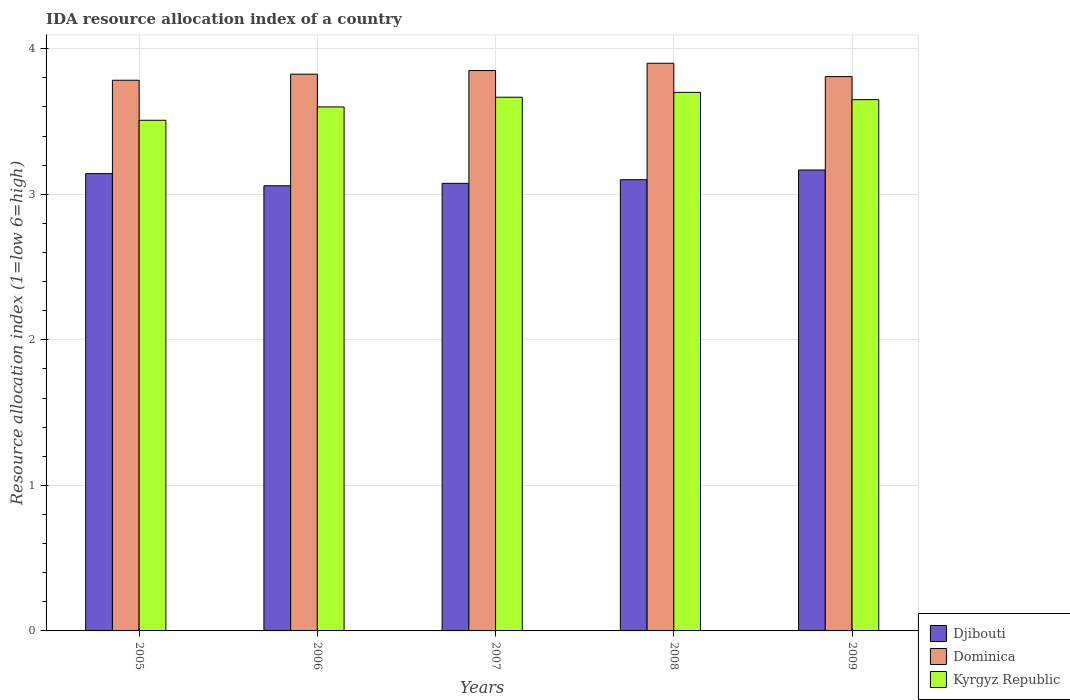How many different coloured bars are there?
Your answer should be very brief. 3. How many groups of bars are there?
Make the answer very short. 5. Are the number of bars per tick equal to the number of legend labels?
Make the answer very short. Yes. How many bars are there on the 5th tick from the left?
Offer a very short reply. 3. How many bars are there on the 3rd tick from the right?
Give a very brief answer. 3. What is the label of the 5th group of bars from the left?
Ensure brevity in your answer.  2009. In how many cases, is the number of bars for a given year not equal to the number of legend labels?
Offer a very short reply. 0. What is the IDA resource allocation index in Djibouti in 2005?
Your answer should be very brief. 3.14. Across all years, what is the minimum IDA resource allocation index in Kyrgyz Republic?
Ensure brevity in your answer.  3.51. In which year was the IDA resource allocation index in Kyrgyz Republic maximum?
Your response must be concise. 2008. What is the total IDA resource allocation index in Kyrgyz Republic in the graph?
Offer a very short reply. 18.12. What is the difference between the IDA resource allocation index in Dominica in 2008 and that in 2009?
Make the answer very short. 0.09. What is the difference between the IDA resource allocation index in Djibouti in 2005 and the IDA resource allocation index in Kyrgyz Republic in 2009?
Give a very brief answer. -0.51. What is the average IDA resource allocation index in Djibouti per year?
Give a very brief answer. 3.11. In the year 2007, what is the difference between the IDA resource allocation index in Dominica and IDA resource allocation index in Kyrgyz Republic?
Your answer should be compact. 0.18. In how many years, is the IDA resource allocation index in Dominica greater than 3.6?
Offer a terse response. 5. What is the ratio of the IDA resource allocation index in Kyrgyz Republic in 2006 to that in 2008?
Your answer should be very brief. 0.97. Is the IDA resource allocation index in Dominica in 2005 less than that in 2009?
Offer a terse response. Yes. What is the difference between the highest and the second highest IDA resource allocation index in Djibouti?
Provide a succinct answer. 0.02. What is the difference between the highest and the lowest IDA resource allocation index in Djibouti?
Your answer should be compact. 0.11. What does the 2nd bar from the left in 2009 represents?
Offer a very short reply. Dominica. What does the 2nd bar from the right in 2009 represents?
Offer a very short reply. Dominica. How many bars are there?
Your answer should be compact. 15. Does the graph contain any zero values?
Offer a very short reply. No. Where does the legend appear in the graph?
Offer a terse response. Bottom right. How are the legend labels stacked?
Your answer should be compact. Vertical. What is the title of the graph?
Give a very brief answer. IDA resource allocation index of a country. What is the label or title of the Y-axis?
Provide a short and direct response. Resource allocation index (1=low 6=high). What is the Resource allocation index (1=low 6=high) in Djibouti in 2005?
Ensure brevity in your answer.  3.14. What is the Resource allocation index (1=low 6=high) of Dominica in 2005?
Keep it short and to the point. 3.78. What is the Resource allocation index (1=low 6=high) of Kyrgyz Republic in 2005?
Provide a succinct answer. 3.51. What is the Resource allocation index (1=low 6=high) in Djibouti in 2006?
Make the answer very short. 3.06. What is the Resource allocation index (1=low 6=high) of Dominica in 2006?
Give a very brief answer. 3.83. What is the Resource allocation index (1=low 6=high) of Kyrgyz Republic in 2006?
Your response must be concise. 3.6. What is the Resource allocation index (1=low 6=high) in Djibouti in 2007?
Give a very brief answer. 3.08. What is the Resource allocation index (1=low 6=high) of Dominica in 2007?
Your answer should be compact. 3.85. What is the Resource allocation index (1=low 6=high) in Kyrgyz Republic in 2007?
Provide a short and direct response. 3.67. What is the Resource allocation index (1=low 6=high) in Kyrgyz Republic in 2008?
Your response must be concise. 3.7. What is the Resource allocation index (1=low 6=high) of Djibouti in 2009?
Provide a succinct answer. 3.17. What is the Resource allocation index (1=low 6=high) of Dominica in 2009?
Keep it short and to the point. 3.81. What is the Resource allocation index (1=low 6=high) in Kyrgyz Republic in 2009?
Your answer should be very brief. 3.65. Across all years, what is the maximum Resource allocation index (1=low 6=high) of Djibouti?
Offer a terse response. 3.17. Across all years, what is the minimum Resource allocation index (1=low 6=high) of Djibouti?
Give a very brief answer. 3.06. Across all years, what is the minimum Resource allocation index (1=low 6=high) of Dominica?
Offer a very short reply. 3.78. Across all years, what is the minimum Resource allocation index (1=low 6=high) in Kyrgyz Republic?
Your answer should be very brief. 3.51. What is the total Resource allocation index (1=low 6=high) of Djibouti in the graph?
Make the answer very short. 15.54. What is the total Resource allocation index (1=low 6=high) in Dominica in the graph?
Provide a short and direct response. 19.17. What is the total Resource allocation index (1=low 6=high) in Kyrgyz Republic in the graph?
Make the answer very short. 18.12. What is the difference between the Resource allocation index (1=low 6=high) of Djibouti in 2005 and that in 2006?
Your answer should be compact. 0.08. What is the difference between the Resource allocation index (1=low 6=high) of Dominica in 2005 and that in 2006?
Your answer should be very brief. -0.04. What is the difference between the Resource allocation index (1=low 6=high) of Kyrgyz Republic in 2005 and that in 2006?
Offer a terse response. -0.09. What is the difference between the Resource allocation index (1=low 6=high) in Djibouti in 2005 and that in 2007?
Your response must be concise. 0.07. What is the difference between the Resource allocation index (1=low 6=high) in Dominica in 2005 and that in 2007?
Your answer should be very brief. -0.07. What is the difference between the Resource allocation index (1=low 6=high) in Kyrgyz Republic in 2005 and that in 2007?
Provide a short and direct response. -0.16. What is the difference between the Resource allocation index (1=low 6=high) in Djibouti in 2005 and that in 2008?
Your answer should be compact. 0.04. What is the difference between the Resource allocation index (1=low 6=high) of Dominica in 2005 and that in 2008?
Offer a very short reply. -0.12. What is the difference between the Resource allocation index (1=low 6=high) in Kyrgyz Republic in 2005 and that in 2008?
Provide a succinct answer. -0.19. What is the difference between the Resource allocation index (1=low 6=high) in Djibouti in 2005 and that in 2009?
Your answer should be very brief. -0.03. What is the difference between the Resource allocation index (1=low 6=high) in Dominica in 2005 and that in 2009?
Your answer should be very brief. -0.03. What is the difference between the Resource allocation index (1=low 6=high) in Kyrgyz Republic in 2005 and that in 2009?
Offer a terse response. -0.14. What is the difference between the Resource allocation index (1=low 6=high) of Djibouti in 2006 and that in 2007?
Your response must be concise. -0.02. What is the difference between the Resource allocation index (1=low 6=high) in Dominica in 2006 and that in 2007?
Make the answer very short. -0.03. What is the difference between the Resource allocation index (1=low 6=high) of Kyrgyz Republic in 2006 and that in 2007?
Give a very brief answer. -0.07. What is the difference between the Resource allocation index (1=low 6=high) of Djibouti in 2006 and that in 2008?
Make the answer very short. -0.04. What is the difference between the Resource allocation index (1=low 6=high) in Dominica in 2006 and that in 2008?
Provide a succinct answer. -0.07. What is the difference between the Resource allocation index (1=low 6=high) of Kyrgyz Republic in 2006 and that in 2008?
Give a very brief answer. -0.1. What is the difference between the Resource allocation index (1=low 6=high) of Djibouti in 2006 and that in 2009?
Provide a short and direct response. -0.11. What is the difference between the Resource allocation index (1=low 6=high) in Dominica in 2006 and that in 2009?
Offer a terse response. 0.02. What is the difference between the Resource allocation index (1=low 6=high) in Kyrgyz Republic in 2006 and that in 2009?
Provide a short and direct response. -0.05. What is the difference between the Resource allocation index (1=low 6=high) in Djibouti in 2007 and that in 2008?
Make the answer very short. -0.03. What is the difference between the Resource allocation index (1=low 6=high) in Dominica in 2007 and that in 2008?
Provide a short and direct response. -0.05. What is the difference between the Resource allocation index (1=low 6=high) of Kyrgyz Republic in 2007 and that in 2008?
Offer a terse response. -0.03. What is the difference between the Resource allocation index (1=low 6=high) in Djibouti in 2007 and that in 2009?
Keep it short and to the point. -0.09. What is the difference between the Resource allocation index (1=low 6=high) in Dominica in 2007 and that in 2009?
Make the answer very short. 0.04. What is the difference between the Resource allocation index (1=low 6=high) in Kyrgyz Republic in 2007 and that in 2009?
Your response must be concise. 0.02. What is the difference between the Resource allocation index (1=low 6=high) of Djibouti in 2008 and that in 2009?
Offer a terse response. -0.07. What is the difference between the Resource allocation index (1=low 6=high) of Dominica in 2008 and that in 2009?
Provide a short and direct response. 0.09. What is the difference between the Resource allocation index (1=low 6=high) in Kyrgyz Republic in 2008 and that in 2009?
Your answer should be very brief. 0.05. What is the difference between the Resource allocation index (1=low 6=high) of Djibouti in 2005 and the Resource allocation index (1=low 6=high) of Dominica in 2006?
Give a very brief answer. -0.68. What is the difference between the Resource allocation index (1=low 6=high) in Djibouti in 2005 and the Resource allocation index (1=low 6=high) in Kyrgyz Republic in 2006?
Your response must be concise. -0.46. What is the difference between the Resource allocation index (1=low 6=high) in Dominica in 2005 and the Resource allocation index (1=low 6=high) in Kyrgyz Republic in 2006?
Make the answer very short. 0.18. What is the difference between the Resource allocation index (1=low 6=high) of Djibouti in 2005 and the Resource allocation index (1=low 6=high) of Dominica in 2007?
Provide a short and direct response. -0.71. What is the difference between the Resource allocation index (1=low 6=high) in Djibouti in 2005 and the Resource allocation index (1=low 6=high) in Kyrgyz Republic in 2007?
Offer a very short reply. -0.53. What is the difference between the Resource allocation index (1=low 6=high) in Dominica in 2005 and the Resource allocation index (1=low 6=high) in Kyrgyz Republic in 2007?
Give a very brief answer. 0.12. What is the difference between the Resource allocation index (1=low 6=high) of Djibouti in 2005 and the Resource allocation index (1=low 6=high) of Dominica in 2008?
Offer a very short reply. -0.76. What is the difference between the Resource allocation index (1=low 6=high) of Djibouti in 2005 and the Resource allocation index (1=low 6=high) of Kyrgyz Republic in 2008?
Your answer should be compact. -0.56. What is the difference between the Resource allocation index (1=low 6=high) of Dominica in 2005 and the Resource allocation index (1=low 6=high) of Kyrgyz Republic in 2008?
Offer a very short reply. 0.08. What is the difference between the Resource allocation index (1=low 6=high) in Djibouti in 2005 and the Resource allocation index (1=low 6=high) in Dominica in 2009?
Your response must be concise. -0.67. What is the difference between the Resource allocation index (1=low 6=high) in Djibouti in 2005 and the Resource allocation index (1=low 6=high) in Kyrgyz Republic in 2009?
Provide a short and direct response. -0.51. What is the difference between the Resource allocation index (1=low 6=high) in Dominica in 2005 and the Resource allocation index (1=low 6=high) in Kyrgyz Republic in 2009?
Provide a succinct answer. 0.13. What is the difference between the Resource allocation index (1=low 6=high) of Djibouti in 2006 and the Resource allocation index (1=low 6=high) of Dominica in 2007?
Provide a succinct answer. -0.79. What is the difference between the Resource allocation index (1=low 6=high) in Djibouti in 2006 and the Resource allocation index (1=low 6=high) in Kyrgyz Republic in 2007?
Offer a terse response. -0.61. What is the difference between the Resource allocation index (1=low 6=high) in Dominica in 2006 and the Resource allocation index (1=low 6=high) in Kyrgyz Republic in 2007?
Give a very brief answer. 0.16. What is the difference between the Resource allocation index (1=low 6=high) in Djibouti in 2006 and the Resource allocation index (1=low 6=high) in Dominica in 2008?
Provide a succinct answer. -0.84. What is the difference between the Resource allocation index (1=low 6=high) of Djibouti in 2006 and the Resource allocation index (1=low 6=high) of Kyrgyz Republic in 2008?
Your answer should be very brief. -0.64. What is the difference between the Resource allocation index (1=low 6=high) in Dominica in 2006 and the Resource allocation index (1=low 6=high) in Kyrgyz Republic in 2008?
Make the answer very short. 0.12. What is the difference between the Resource allocation index (1=low 6=high) of Djibouti in 2006 and the Resource allocation index (1=low 6=high) of Dominica in 2009?
Offer a very short reply. -0.75. What is the difference between the Resource allocation index (1=low 6=high) in Djibouti in 2006 and the Resource allocation index (1=low 6=high) in Kyrgyz Republic in 2009?
Keep it short and to the point. -0.59. What is the difference between the Resource allocation index (1=low 6=high) of Dominica in 2006 and the Resource allocation index (1=low 6=high) of Kyrgyz Republic in 2009?
Your answer should be very brief. 0.17. What is the difference between the Resource allocation index (1=low 6=high) of Djibouti in 2007 and the Resource allocation index (1=low 6=high) of Dominica in 2008?
Your answer should be very brief. -0.82. What is the difference between the Resource allocation index (1=low 6=high) of Djibouti in 2007 and the Resource allocation index (1=low 6=high) of Kyrgyz Republic in 2008?
Make the answer very short. -0.62. What is the difference between the Resource allocation index (1=low 6=high) of Dominica in 2007 and the Resource allocation index (1=low 6=high) of Kyrgyz Republic in 2008?
Provide a short and direct response. 0.15. What is the difference between the Resource allocation index (1=low 6=high) in Djibouti in 2007 and the Resource allocation index (1=low 6=high) in Dominica in 2009?
Offer a terse response. -0.73. What is the difference between the Resource allocation index (1=low 6=high) in Djibouti in 2007 and the Resource allocation index (1=low 6=high) in Kyrgyz Republic in 2009?
Provide a succinct answer. -0.57. What is the difference between the Resource allocation index (1=low 6=high) in Djibouti in 2008 and the Resource allocation index (1=low 6=high) in Dominica in 2009?
Provide a succinct answer. -0.71. What is the difference between the Resource allocation index (1=low 6=high) in Djibouti in 2008 and the Resource allocation index (1=low 6=high) in Kyrgyz Republic in 2009?
Your response must be concise. -0.55. What is the average Resource allocation index (1=low 6=high) of Djibouti per year?
Offer a very short reply. 3.11. What is the average Resource allocation index (1=low 6=high) in Dominica per year?
Offer a very short reply. 3.83. What is the average Resource allocation index (1=low 6=high) in Kyrgyz Republic per year?
Provide a short and direct response. 3.62. In the year 2005, what is the difference between the Resource allocation index (1=low 6=high) in Djibouti and Resource allocation index (1=low 6=high) in Dominica?
Give a very brief answer. -0.64. In the year 2005, what is the difference between the Resource allocation index (1=low 6=high) in Djibouti and Resource allocation index (1=low 6=high) in Kyrgyz Republic?
Make the answer very short. -0.37. In the year 2005, what is the difference between the Resource allocation index (1=low 6=high) of Dominica and Resource allocation index (1=low 6=high) of Kyrgyz Republic?
Your response must be concise. 0.28. In the year 2006, what is the difference between the Resource allocation index (1=low 6=high) in Djibouti and Resource allocation index (1=low 6=high) in Dominica?
Your answer should be compact. -0.77. In the year 2006, what is the difference between the Resource allocation index (1=low 6=high) in Djibouti and Resource allocation index (1=low 6=high) in Kyrgyz Republic?
Your answer should be compact. -0.54. In the year 2006, what is the difference between the Resource allocation index (1=low 6=high) of Dominica and Resource allocation index (1=low 6=high) of Kyrgyz Republic?
Provide a short and direct response. 0.23. In the year 2007, what is the difference between the Resource allocation index (1=low 6=high) in Djibouti and Resource allocation index (1=low 6=high) in Dominica?
Offer a terse response. -0.78. In the year 2007, what is the difference between the Resource allocation index (1=low 6=high) of Djibouti and Resource allocation index (1=low 6=high) of Kyrgyz Republic?
Offer a very short reply. -0.59. In the year 2007, what is the difference between the Resource allocation index (1=low 6=high) of Dominica and Resource allocation index (1=low 6=high) of Kyrgyz Republic?
Offer a terse response. 0.18. In the year 2008, what is the difference between the Resource allocation index (1=low 6=high) in Djibouti and Resource allocation index (1=low 6=high) in Kyrgyz Republic?
Your answer should be very brief. -0.6. In the year 2008, what is the difference between the Resource allocation index (1=low 6=high) in Dominica and Resource allocation index (1=low 6=high) in Kyrgyz Republic?
Ensure brevity in your answer.  0.2. In the year 2009, what is the difference between the Resource allocation index (1=low 6=high) of Djibouti and Resource allocation index (1=low 6=high) of Dominica?
Keep it short and to the point. -0.64. In the year 2009, what is the difference between the Resource allocation index (1=low 6=high) of Djibouti and Resource allocation index (1=low 6=high) of Kyrgyz Republic?
Provide a succinct answer. -0.48. In the year 2009, what is the difference between the Resource allocation index (1=low 6=high) in Dominica and Resource allocation index (1=low 6=high) in Kyrgyz Republic?
Provide a short and direct response. 0.16. What is the ratio of the Resource allocation index (1=low 6=high) of Djibouti in 2005 to that in 2006?
Provide a short and direct response. 1.03. What is the ratio of the Resource allocation index (1=low 6=high) of Kyrgyz Republic in 2005 to that in 2006?
Provide a short and direct response. 0.97. What is the ratio of the Resource allocation index (1=low 6=high) of Djibouti in 2005 to that in 2007?
Offer a terse response. 1.02. What is the ratio of the Resource allocation index (1=low 6=high) in Dominica in 2005 to that in 2007?
Offer a terse response. 0.98. What is the ratio of the Resource allocation index (1=low 6=high) of Kyrgyz Republic in 2005 to that in 2007?
Give a very brief answer. 0.96. What is the ratio of the Resource allocation index (1=low 6=high) in Djibouti in 2005 to that in 2008?
Give a very brief answer. 1.01. What is the ratio of the Resource allocation index (1=low 6=high) of Dominica in 2005 to that in 2008?
Keep it short and to the point. 0.97. What is the ratio of the Resource allocation index (1=low 6=high) of Kyrgyz Republic in 2005 to that in 2008?
Provide a short and direct response. 0.95. What is the ratio of the Resource allocation index (1=low 6=high) of Djibouti in 2005 to that in 2009?
Provide a short and direct response. 0.99. What is the ratio of the Resource allocation index (1=low 6=high) of Kyrgyz Republic in 2005 to that in 2009?
Your answer should be very brief. 0.96. What is the ratio of the Resource allocation index (1=low 6=high) of Djibouti in 2006 to that in 2007?
Offer a very short reply. 0.99. What is the ratio of the Resource allocation index (1=low 6=high) of Dominica in 2006 to that in 2007?
Give a very brief answer. 0.99. What is the ratio of the Resource allocation index (1=low 6=high) of Kyrgyz Republic in 2006 to that in 2007?
Your answer should be compact. 0.98. What is the ratio of the Resource allocation index (1=low 6=high) of Djibouti in 2006 to that in 2008?
Give a very brief answer. 0.99. What is the ratio of the Resource allocation index (1=low 6=high) in Dominica in 2006 to that in 2008?
Your response must be concise. 0.98. What is the ratio of the Resource allocation index (1=low 6=high) of Djibouti in 2006 to that in 2009?
Provide a short and direct response. 0.97. What is the ratio of the Resource allocation index (1=low 6=high) of Dominica in 2006 to that in 2009?
Provide a short and direct response. 1. What is the ratio of the Resource allocation index (1=low 6=high) of Kyrgyz Republic in 2006 to that in 2009?
Your response must be concise. 0.99. What is the ratio of the Resource allocation index (1=low 6=high) in Dominica in 2007 to that in 2008?
Ensure brevity in your answer.  0.99. What is the ratio of the Resource allocation index (1=low 6=high) in Djibouti in 2007 to that in 2009?
Provide a short and direct response. 0.97. What is the ratio of the Resource allocation index (1=low 6=high) of Dominica in 2007 to that in 2009?
Give a very brief answer. 1.01. What is the ratio of the Resource allocation index (1=low 6=high) in Kyrgyz Republic in 2007 to that in 2009?
Your answer should be compact. 1. What is the ratio of the Resource allocation index (1=low 6=high) in Djibouti in 2008 to that in 2009?
Offer a very short reply. 0.98. What is the ratio of the Resource allocation index (1=low 6=high) in Dominica in 2008 to that in 2009?
Make the answer very short. 1.02. What is the ratio of the Resource allocation index (1=low 6=high) in Kyrgyz Republic in 2008 to that in 2009?
Ensure brevity in your answer.  1.01. What is the difference between the highest and the second highest Resource allocation index (1=low 6=high) of Djibouti?
Ensure brevity in your answer.  0.03. What is the difference between the highest and the second highest Resource allocation index (1=low 6=high) in Kyrgyz Republic?
Your answer should be very brief. 0.03. What is the difference between the highest and the lowest Resource allocation index (1=low 6=high) in Djibouti?
Provide a succinct answer. 0.11. What is the difference between the highest and the lowest Resource allocation index (1=low 6=high) of Dominica?
Offer a very short reply. 0.12. What is the difference between the highest and the lowest Resource allocation index (1=low 6=high) in Kyrgyz Republic?
Make the answer very short. 0.19. 